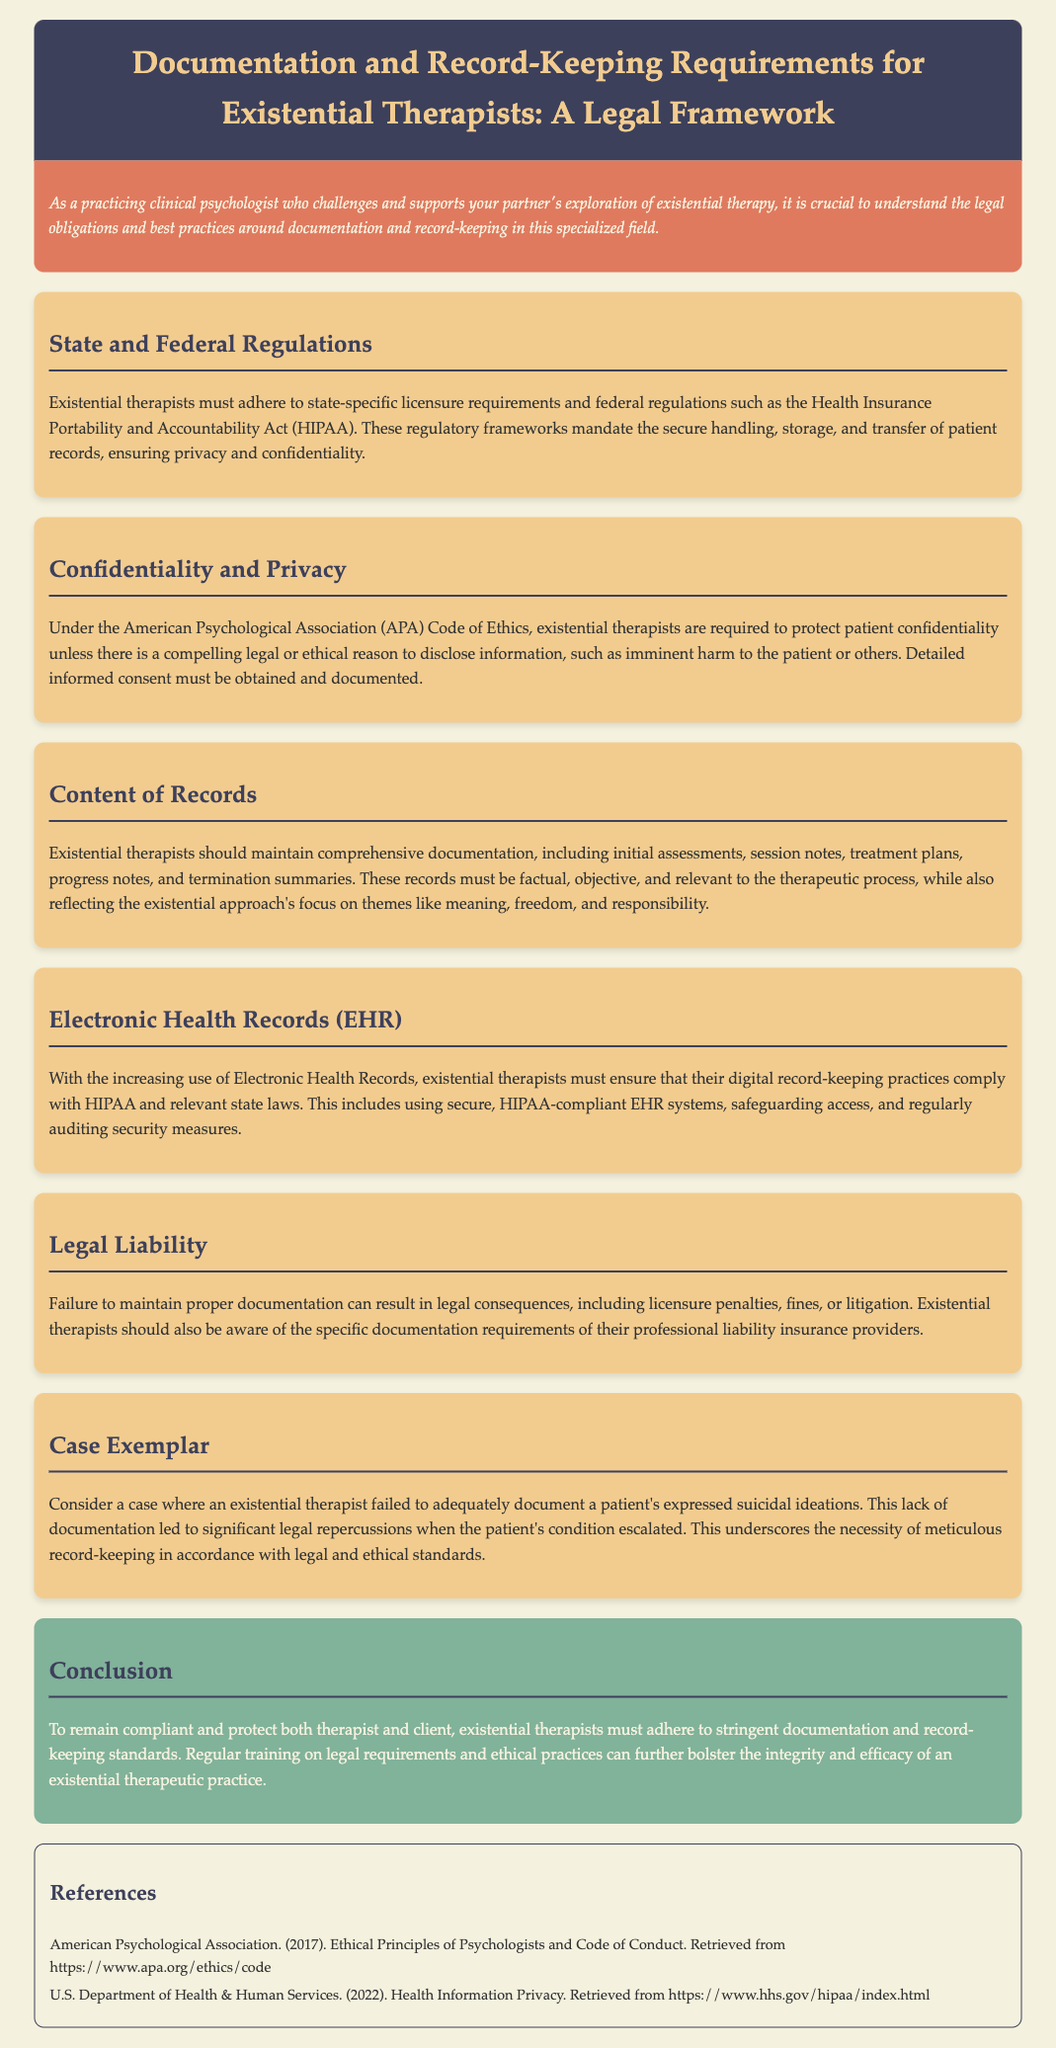What are existential therapists required to adhere to in terms of regulations? The document states that existential therapists must adhere to state-specific licensure requirements and federal regulations such as HIPAA.
Answer: state-specific licensure and HIPAA What does the APA Code of Ethics require from existential therapists regarding patient information? The document mentions that existential therapists are required to protect patient confidentiality unless there is a compelling legal or ethical reason to disclose information.
Answer: protect patient confidentiality What kinds of records should existential therapists maintain? The content states that therapists should maintain comprehensive documentation, including initial assessments, session notes, treatment plans, progress notes, and termination summaries.
Answer: Initial assessments, session notes, treatment plans, progress notes, termination summaries Which federal act governs the handling of patient records? The brief indicates that the Health Insurance Portability and Accountability Act governs the secure handling of patient records.
Answer: Health Insurance Portability and Accountability Act What might happen if proper documentation is not maintained by existential therapists? The document outlines that failure to maintain proper documentation can result in legal consequences including licensure penalties, fines, or litigation.
Answer: legal consequences How can existential therapists protect their digital records? It emphasizes that therapists must ensure their digital record-keeping practices comply with HIPAA and relevant state laws, including using secure EHR systems.
Answer: comply with HIPAA and use secure EHR systems What does the case exemplar illustrate regarding documentation? The case exemplar highlights the necessity of meticulous record-keeping in accordance with legal and ethical standards, using a specific incident about suicidal ideations.
Answer: necessity of meticulous record-keeping What is the main conclusion drawn in the brief? The conclusion asserts that existential therapists must adhere to stringent documentation and record-keeping standards to remain compliant and protect both therapist and client.
Answer: adhere to stringent documentation standards 